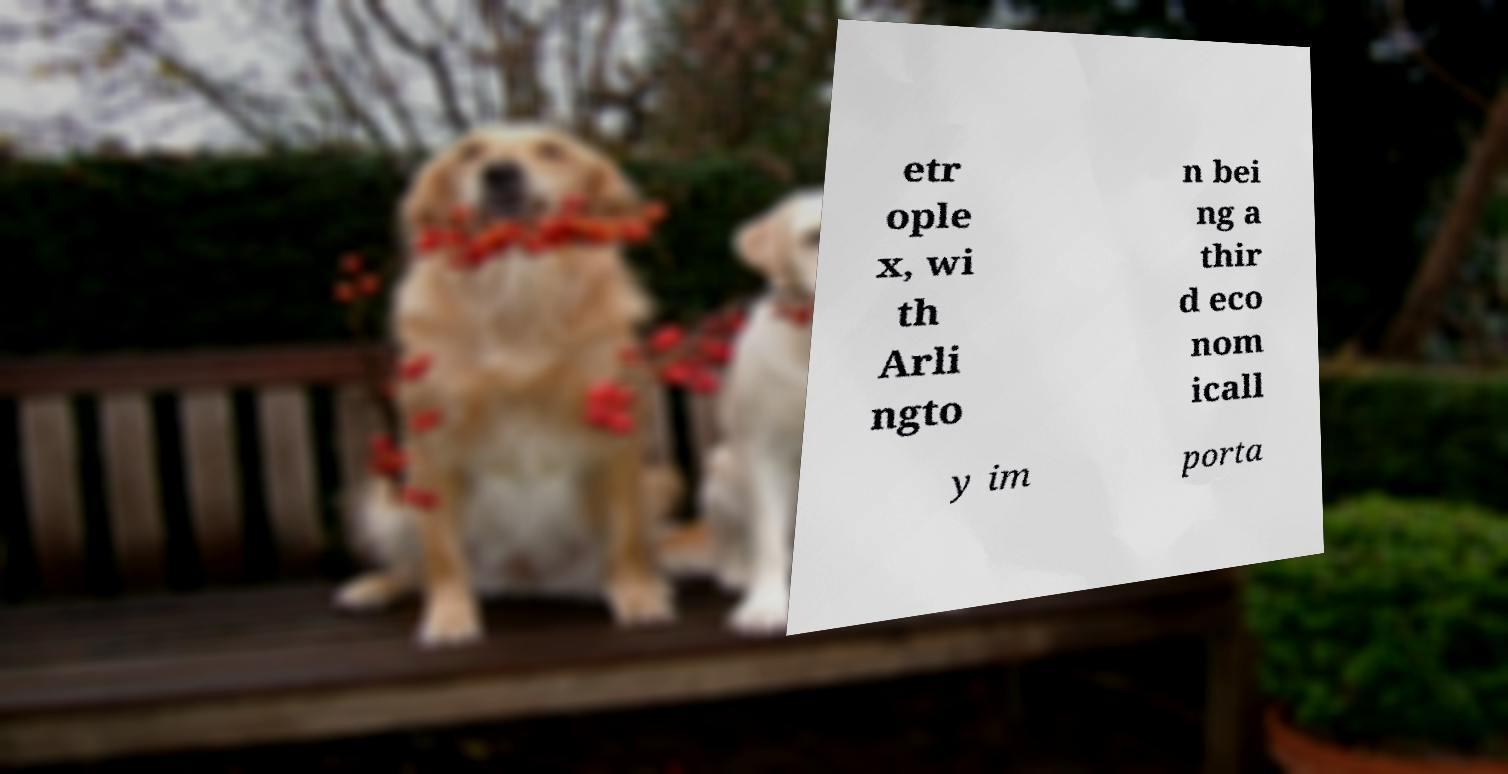Can you read and provide the text displayed in the image?This photo seems to have some interesting text. Can you extract and type it out for me? etr ople x, wi th Arli ngto n bei ng a thir d eco nom icall y im porta 